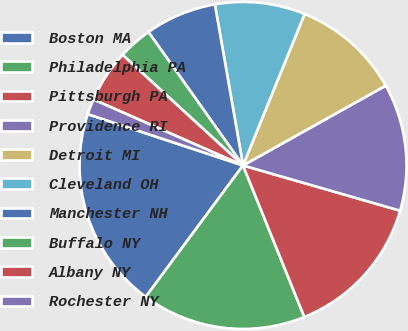<chart> <loc_0><loc_0><loc_500><loc_500><pie_chart><fcel>Boston MA<fcel>Philadelphia PA<fcel>Pittsburgh PA<fcel>Providence RI<fcel>Detroit MI<fcel>Cleveland OH<fcel>Manchester NH<fcel>Buffalo NY<fcel>Albany NY<fcel>Rochester NY<nl><fcel>19.94%<fcel>16.26%<fcel>14.42%<fcel>12.58%<fcel>10.74%<fcel>8.9%<fcel>7.06%<fcel>3.37%<fcel>5.21%<fcel>1.53%<nl></chart> 